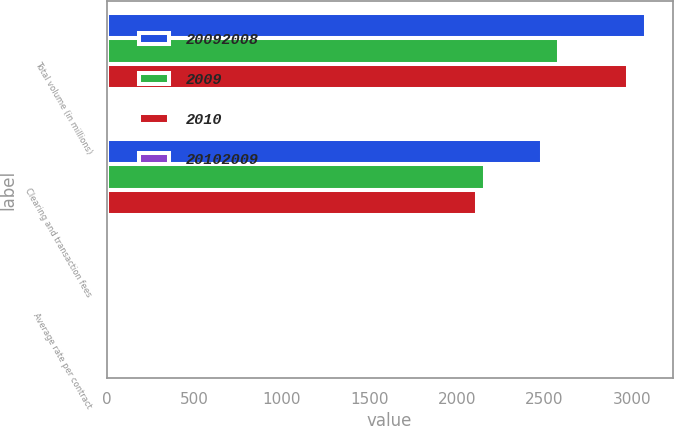Convert chart to OTSL. <chart><loc_0><loc_0><loc_500><loc_500><stacked_bar_chart><ecel><fcel>Total volume (in millions)<fcel>Clearing and transaction fees<fcel>Average rate per contract<nl><fcel>2.0092e+07<fcel>3078.1<fcel>2486.3<fcel>0.81<nl><fcel>2009<fcel>2584.9<fcel>2161.7<fcel>0.84<nl><fcel>2010<fcel>2978.5<fcel>2114.7<fcel>0.71<nl><fcel>2.0102e+07<fcel>19<fcel>15<fcel>3<nl></chart> 